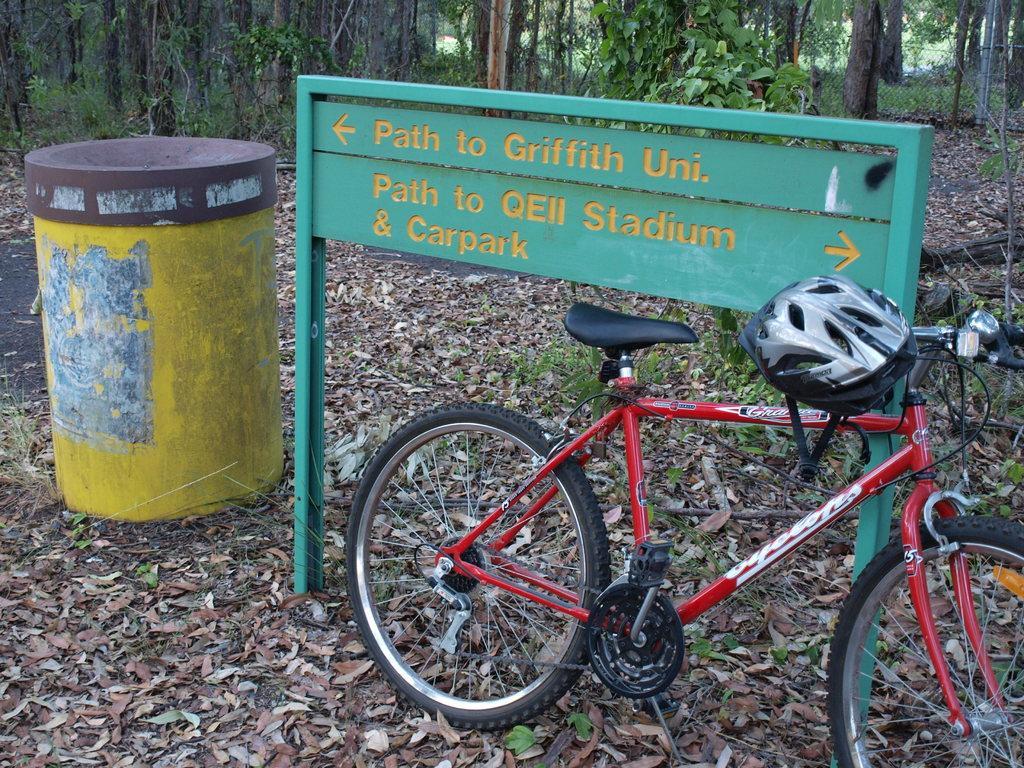Describe this image in one or two sentences. In this image there are trees towards the top of the image, there is a fence towards the right of the image, there is a board, there is text on the board, there is a bicycle towards the bottom of the image, there is a helmet, there is ground towards the bottom of the image, there are dried leaves on the ground, there are objects on the ground. 